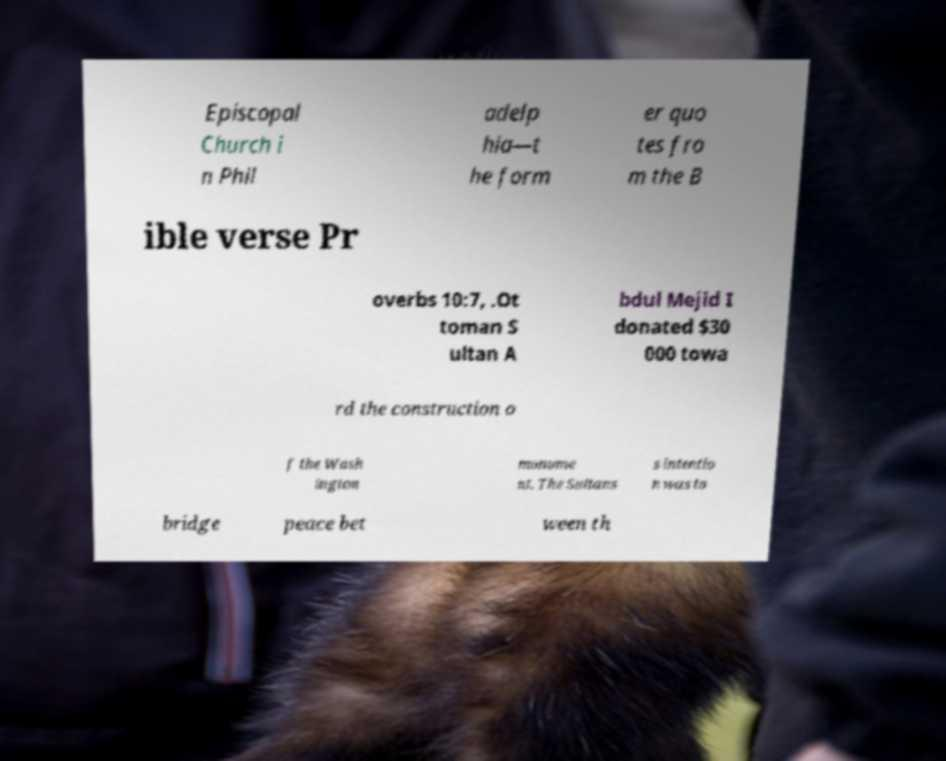Can you accurately transcribe the text from the provided image for me? Episcopal Church i n Phil adelp hia—t he form er quo tes fro m the B ible verse Pr overbs 10:7, .Ot toman S ultan A bdul Mejid I donated $30 000 towa rd the construction o f the Wash ington monume nt. The Sultans s intentio n was to bridge peace bet ween th 